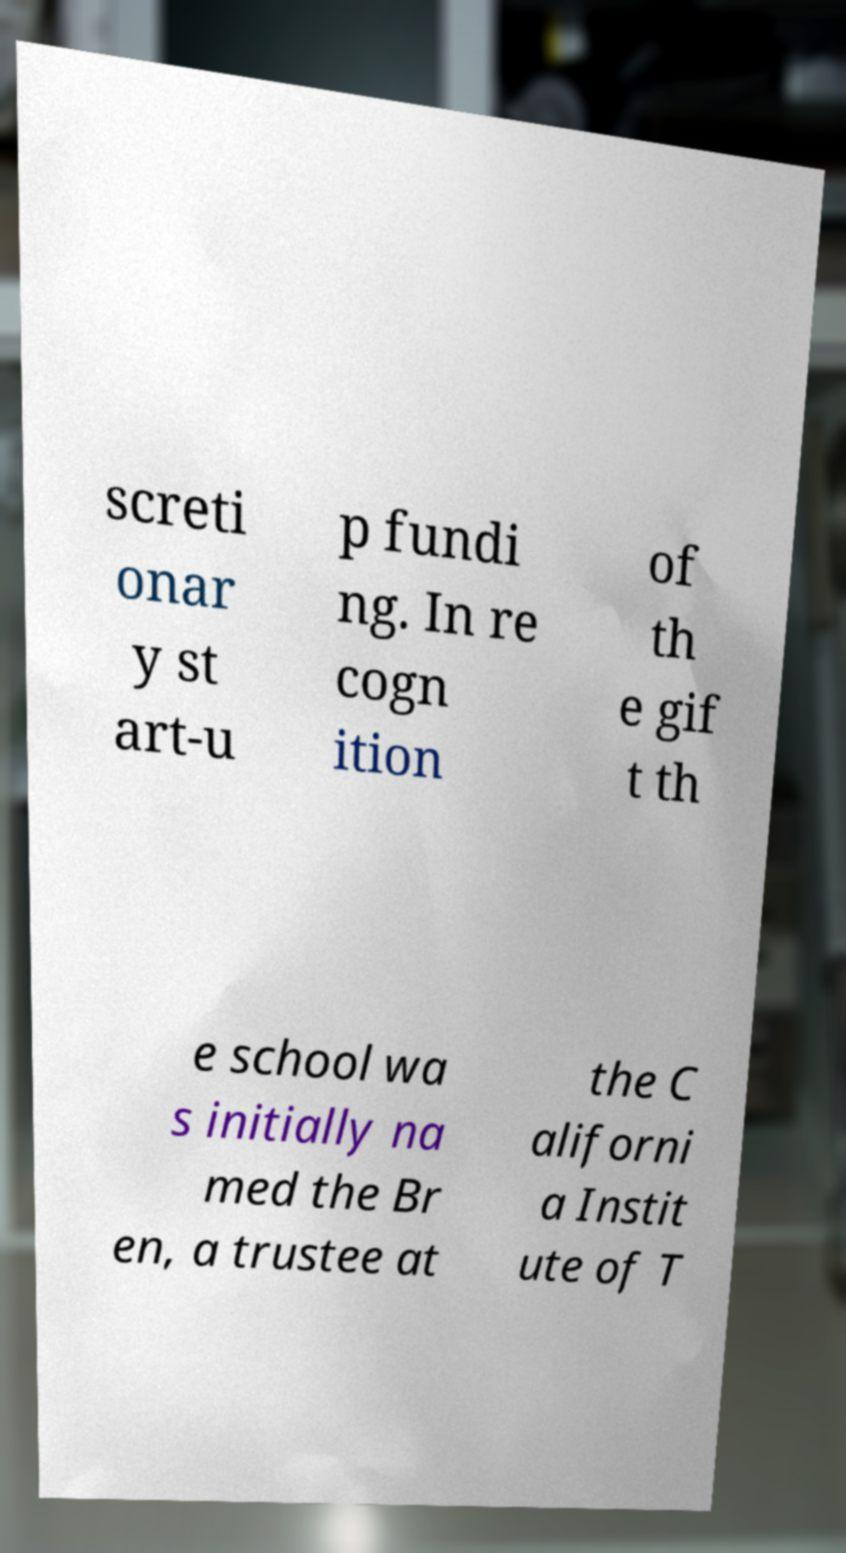What messages or text are displayed in this image? I need them in a readable, typed format. screti onar y st art-u p fundi ng. In re cogn ition of th e gif t th e school wa s initially na med the Br en, a trustee at the C aliforni a Instit ute of T 